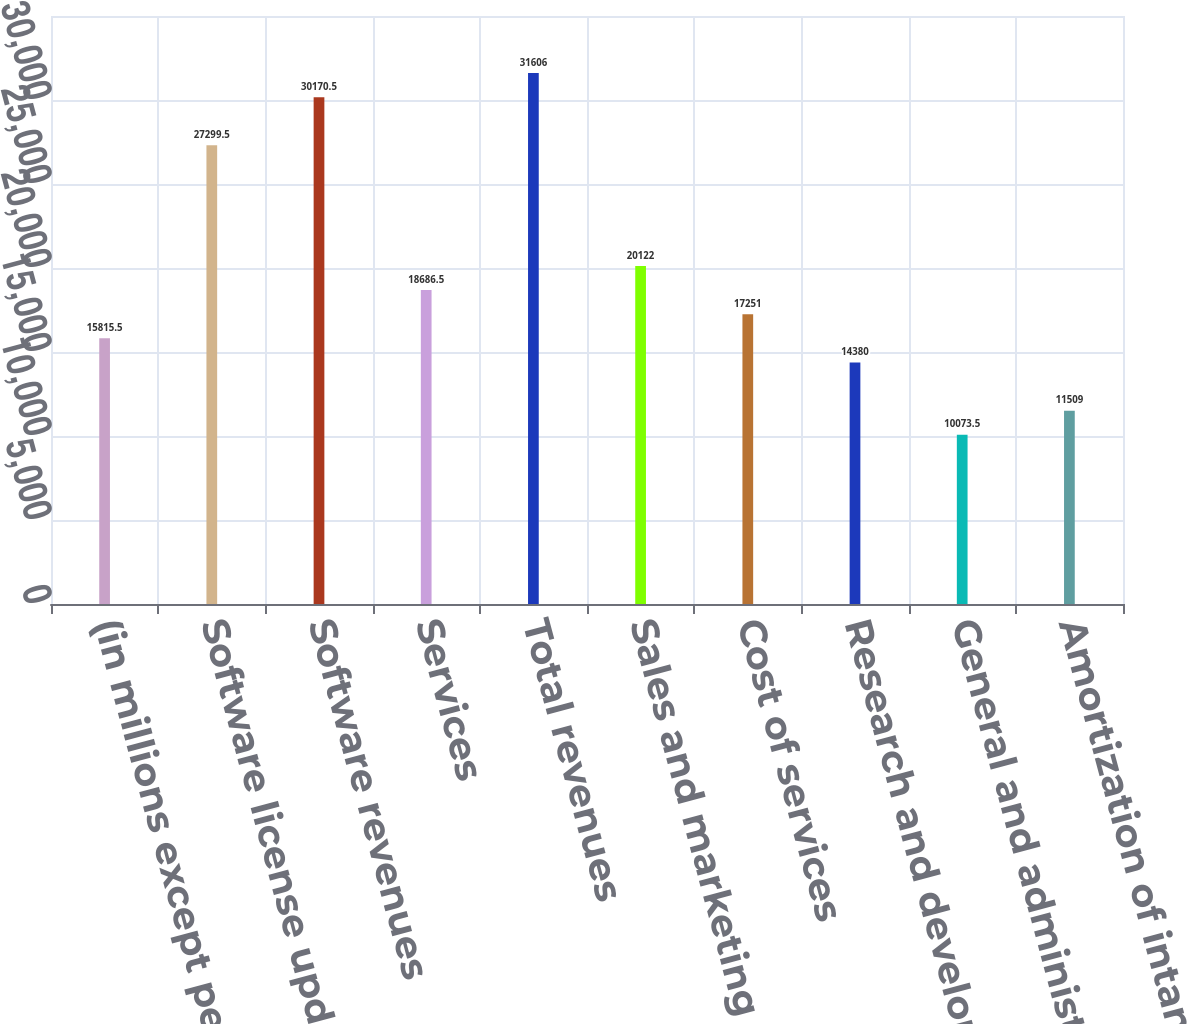<chart> <loc_0><loc_0><loc_500><loc_500><bar_chart><fcel>(in millions except per share<fcel>Software license updates and<fcel>Software revenues<fcel>Services<fcel>Total revenues<fcel>Sales and marketing<fcel>Cost of services<fcel>Research and development<fcel>General and administrative<fcel>Amortization of intangible<nl><fcel>15815.5<fcel>27299.5<fcel>30170.5<fcel>18686.5<fcel>31606<fcel>20122<fcel>17251<fcel>14380<fcel>10073.5<fcel>11509<nl></chart> 